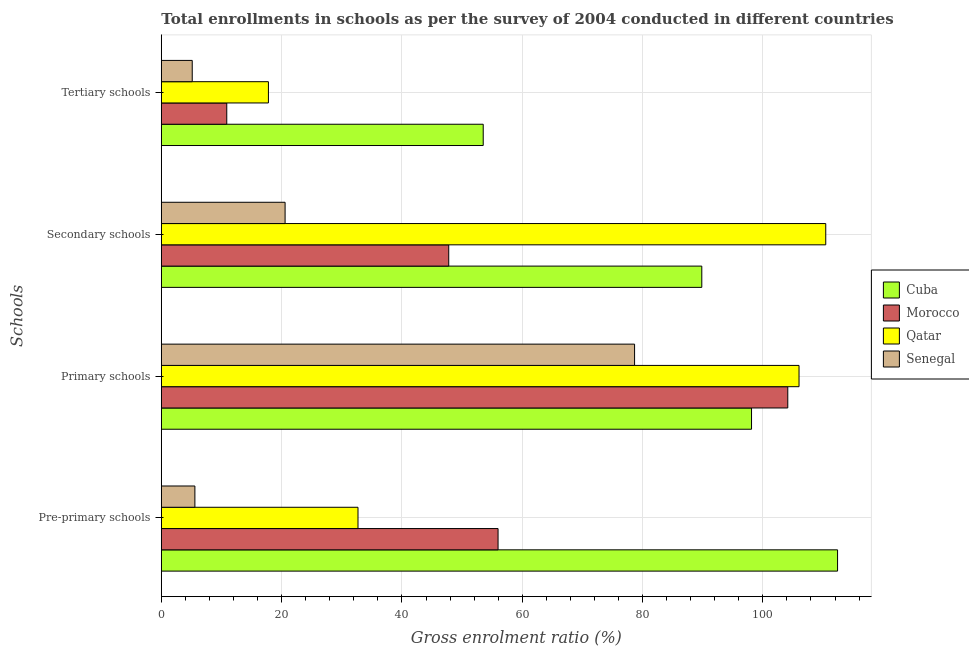How many different coloured bars are there?
Make the answer very short. 4. Are the number of bars per tick equal to the number of legend labels?
Offer a terse response. Yes. Are the number of bars on each tick of the Y-axis equal?
Ensure brevity in your answer.  Yes. How many bars are there on the 3rd tick from the bottom?
Give a very brief answer. 4. What is the label of the 2nd group of bars from the top?
Make the answer very short. Secondary schools. What is the gross enrolment ratio in tertiary schools in Cuba?
Offer a terse response. 53.51. Across all countries, what is the maximum gross enrolment ratio in pre-primary schools?
Provide a short and direct response. 112.42. Across all countries, what is the minimum gross enrolment ratio in tertiary schools?
Give a very brief answer. 5.14. In which country was the gross enrolment ratio in primary schools maximum?
Ensure brevity in your answer.  Qatar. In which country was the gross enrolment ratio in tertiary schools minimum?
Your response must be concise. Senegal. What is the total gross enrolment ratio in pre-primary schools in the graph?
Give a very brief answer. 206.68. What is the difference between the gross enrolment ratio in secondary schools in Qatar and that in Morocco?
Your answer should be compact. 62.67. What is the difference between the gross enrolment ratio in tertiary schools in Qatar and the gross enrolment ratio in primary schools in Morocco?
Give a very brief answer. -86.34. What is the average gross enrolment ratio in tertiary schools per country?
Offer a very short reply. 21.83. What is the difference between the gross enrolment ratio in primary schools and gross enrolment ratio in pre-primary schools in Qatar?
Offer a very short reply. 73.32. What is the ratio of the gross enrolment ratio in pre-primary schools in Morocco to that in Qatar?
Your answer should be very brief. 1.71. Is the difference between the gross enrolment ratio in secondary schools in Cuba and Senegal greater than the difference between the gross enrolment ratio in primary schools in Cuba and Senegal?
Your response must be concise. Yes. What is the difference between the highest and the second highest gross enrolment ratio in tertiary schools?
Provide a succinct answer. 35.71. What is the difference between the highest and the lowest gross enrolment ratio in primary schools?
Keep it short and to the point. 27.34. What does the 4th bar from the top in Secondary schools represents?
Provide a succinct answer. Cuba. What does the 3rd bar from the bottom in Secondary schools represents?
Keep it short and to the point. Qatar. Is it the case that in every country, the sum of the gross enrolment ratio in pre-primary schools and gross enrolment ratio in primary schools is greater than the gross enrolment ratio in secondary schools?
Give a very brief answer. Yes. How many bars are there?
Keep it short and to the point. 16. What is the difference between two consecutive major ticks on the X-axis?
Offer a very short reply. 20. Does the graph contain grids?
Provide a short and direct response. Yes. Where does the legend appear in the graph?
Offer a terse response. Center right. What is the title of the graph?
Your answer should be compact. Total enrollments in schools as per the survey of 2004 conducted in different countries. Does "Yemen, Rep." appear as one of the legend labels in the graph?
Give a very brief answer. No. What is the label or title of the Y-axis?
Make the answer very short. Schools. What is the Gross enrolment ratio (%) of Cuba in Pre-primary schools?
Your response must be concise. 112.42. What is the Gross enrolment ratio (%) in Morocco in Pre-primary schools?
Provide a short and direct response. 55.98. What is the Gross enrolment ratio (%) in Qatar in Pre-primary schools?
Provide a short and direct response. 32.7. What is the Gross enrolment ratio (%) of Senegal in Pre-primary schools?
Give a very brief answer. 5.58. What is the Gross enrolment ratio (%) in Cuba in Primary schools?
Offer a very short reply. 98.12. What is the Gross enrolment ratio (%) of Morocco in Primary schools?
Provide a short and direct response. 104.14. What is the Gross enrolment ratio (%) of Qatar in Primary schools?
Make the answer very short. 106.01. What is the Gross enrolment ratio (%) in Senegal in Primary schools?
Provide a succinct answer. 78.67. What is the Gross enrolment ratio (%) in Cuba in Secondary schools?
Keep it short and to the point. 89.85. What is the Gross enrolment ratio (%) of Morocco in Secondary schools?
Make the answer very short. 47.78. What is the Gross enrolment ratio (%) in Qatar in Secondary schools?
Your answer should be compact. 110.45. What is the Gross enrolment ratio (%) in Senegal in Secondary schools?
Your answer should be compact. 20.58. What is the Gross enrolment ratio (%) of Cuba in Tertiary schools?
Give a very brief answer. 53.51. What is the Gross enrolment ratio (%) in Morocco in Tertiary schools?
Give a very brief answer. 10.88. What is the Gross enrolment ratio (%) of Qatar in Tertiary schools?
Make the answer very short. 17.81. What is the Gross enrolment ratio (%) of Senegal in Tertiary schools?
Offer a terse response. 5.14. Across all Schools, what is the maximum Gross enrolment ratio (%) in Cuba?
Ensure brevity in your answer.  112.42. Across all Schools, what is the maximum Gross enrolment ratio (%) in Morocco?
Keep it short and to the point. 104.14. Across all Schools, what is the maximum Gross enrolment ratio (%) in Qatar?
Your response must be concise. 110.45. Across all Schools, what is the maximum Gross enrolment ratio (%) in Senegal?
Make the answer very short. 78.67. Across all Schools, what is the minimum Gross enrolment ratio (%) in Cuba?
Give a very brief answer. 53.51. Across all Schools, what is the minimum Gross enrolment ratio (%) of Morocco?
Offer a terse response. 10.88. Across all Schools, what is the minimum Gross enrolment ratio (%) of Qatar?
Your answer should be compact. 17.81. Across all Schools, what is the minimum Gross enrolment ratio (%) of Senegal?
Keep it short and to the point. 5.14. What is the total Gross enrolment ratio (%) in Cuba in the graph?
Offer a terse response. 353.89. What is the total Gross enrolment ratio (%) of Morocco in the graph?
Offer a very short reply. 218.78. What is the total Gross enrolment ratio (%) in Qatar in the graph?
Give a very brief answer. 266.97. What is the total Gross enrolment ratio (%) of Senegal in the graph?
Your response must be concise. 109.97. What is the difference between the Gross enrolment ratio (%) in Cuba in Pre-primary schools and that in Primary schools?
Offer a terse response. 14.3. What is the difference between the Gross enrolment ratio (%) of Morocco in Pre-primary schools and that in Primary schools?
Provide a succinct answer. -48.16. What is the difference between the Gross enrolment ratio (%) of Qatar in Pre-primary schools and that in Primary schools?
Your response must be concise. -73.32. What is the difference between the Gross enrolment ratio (%) of Senegal in Pre-primary schools and that in Primary schools?
Your answer should be very brief. -73.09. What is the difference between the Gross enrolment ratio (%) of Cuba in Pre-primary schools and that in Secondary schools?
Ensure brevity in your answer.  22.57. What is the difference between the Gross enrolment ratio (%) of Morocco in Pre-primary schools and that in Secondary schools?
Your answer should be compact. 8.2. What is the difference between the Gross enrolment ratio (%) of Qatar in Pre-primary schools and that in Secondary schools?
Your answer should be compact. -77.76. What is the difference between the Gross enrolment ratio (%) of Senegal in Pre-primary schools and that in Secondary schools?
Your response must be concise. -14.99. What is the difference between the Gross enrolment ratio (%) in Cuba in Pre-primary schools and that in Tertiary schools?
Your answer should be very brief. 58.91. What is the difference between the Gross enrolment ratio (%) of Morocco in Pre-primary schools and that in Tertiary schools?
Keep it short and to the point. 45.1. What is the difference between the Gross enrolment ratio (%) in Qatar in Pre-primary schools and that in Tertiary schools?
Keep it short and to the point. 14.89. What is the difference between the Gross enrolment ratio (%) in Senegal in Pre-primary schools and that in Tertiary schools?
Your response must be concise. 0.44. What is the difference between the Gross enrolment ratio (%) in Cuba in Primary schools and that in Secondary schools?
Offer a terse response. 8.27. What is the difference between the Gross enrolment ratio (%) in Morocco in Primary schools and that in Secondary schools?
Offer a terse response. 56.36. What is the difference between the Gross enrolment ratio (%) of Qatar in Primary schools and that in Secondary schools?
Provide a succinct answer. -4.44. What is the difference between the Gross enrolment ratio (%) of Senegal in Primary schools and that in Secondary schools?
Your response must be concise. 58.1. What is the difference between the Gross enrolment ratio (%) of Cuba in Primary schools and that in Tertiary schools?
Offer a very short reply. 44.6. What is the difference between the Gross enrolment ratio (%) in Morocco in Primary schools and that in Tertiary schools?
Make the answer very short. 93.26. What is the difference between the Gross enrolment ratio (%) of Qatar in Primary schools and that in Tertiary schools?
Your answer should be very brief. 88.21. What is the difference between the Gross enrolment ratio (%) of Senegal in Primary schools and that in Tertiary schools?
Give a very brief answer. 73.53. What is the difference between the Gross enrolment ratio (%) of Cuba in Secondary schools and that in Tertiary schools?
Give a very brief answer. 36.34. What is the difference between the Gross enrolment ratio (%) of Morocco in Secondary schools and that in Tertiary schools?
Offer a terse response. 36.9. What is the difference between the Gross enrolment ratio (%) of Qatar in Secondary schools and that in Tertiary schools?
Provide a succinct answer. 92.65. What is the difference between the Gross enrolment ratio (%) in Senegal in Secondary schools and that in Tertiary schools?
Your answer should be very brief. 15.44. What is the difference between the Gross enrolment ratio (%) of Cuba in Pre-primary schools and the Gross enrolment ratio (%) of Morocco in Primary schools?
Give a very brief answer. 8.28. What is the difference between the Gross enrolment ratio (%) in Cuba in Pre-primary schools and the Gross enrolment ratio (%) in Qatar in Primary schools?
Your answer should be very brief. 6.41. What is the difference between the Gross enrolment ratio (%) of Cuba in Pre-primary schools and the Gross enrolment ratio (%) of Senegal in Primary schools?
Keep it short and to the point. 33.75. What is the difference between the Gross enrolment ratio (%) in Morocco in Pre-primary schools and the Gross enrolment ratio (%) in Qatar in Primary schools?
Your response must be concise. -50.03. What is the difference between the Gross enrolment ratio (%) in Morocco in Pre-primary schools and the Gross enrolment ratio (%) in Senegal in Primary schools?
Offer a terse response. -22.69. What is the difference between the Gross enrolment ratio (%) of Qatar in Pre-primary schools and the Gross enrolment ratio (%) of Senegal in Primary schools?
Your answer should be compact. -45.98. What is the difference between the Gross enrolment ratio (%) in Cuba in Pre-primary schools and the Gross enrolment ratio (%) in Morocco in Secondary schools?
Give a very brief answer. 64.64. What is the difference between the Gross enrolment ratio (%) in Cuba in Pre-primary schools and the Gross enrolment ratio (%) in Qatar in Secondary schools?
Offer a terse response. 1.97. What is the difference between the Gross enrolment ratio (%) of Cuba in Pre-primary schools and the Gross enrolment ratio (%) of Senegal in Secondary schools?
Offer a very short reply. 91.84. What is the difference between the Gross enrolment ratio (%) in Morocco in Pre-primary schools and the Gross enrolment ratio (%) in Qatar in Secondary schools?
Offer a terse response. -54.47. What is the difference between the Gross enrolment ratio (%) of Morocco in Pre-primary schools and the Gross enrolment ratio (%) of Senegal in Secondary schools?
Keep it short and to the point. 35.4. What is the difference between the Gross enrolment ratio (%) in Qatar in Pre-primary schools and the Gross enrolment ratio (%) in Senegal in Secondary schools?
Provide a short and direct response. 12.12. What is the difference between the Gross enrolment ratio (%) in Cuba in Pre-primary schools and the Gross enrolment ratio (%) in Morocco in Tertiary schools?
Make the answer very short. 101.54. What is the difference between the Gross enrolment ratio (%) in Cuba in Pre-primary schools and the Gross enrolment ratio (%) in Qatar in Tertiary schools?
Your answer should be compact. 94.61. What is the difference between the Gross enrolment ratio (%) in Cuba in Pre-primary schools and the Gross enrolment ratio (%) in Senegal in Tertiary schools?
Your answer should be very brief. 107.28. What is the difference between the Gross enrolment ratio (%) in Morocco in Pre-primary schools and the Gross enrolment ratio (%) in Qatar in Tertiary schools?
Give a very brief answer. 38.17. What is the difference between the Gross enrolment ratio (%) of Morocco in Pre-primary schools and the Gross enrolment ratio (%) of Senegal in Tertiary schools?
Make the answer very short. 50.84. What is the difference between the Gross enrolment ratio (%) of Qatar in Pre-primary schools and the Gross enrolment ratio (%) of Senegal in Tertiary schools?
Your answer should be compact. 27.56. What is the difference between the Gross enrolment ratio (%) in Cuba in Primary schools and the Gross enrolment ratio (%) in Morocco in Secondary schools?
Provide a succinct answer. 50.34. What is the difference between the Gross enrolment ratio (%) in Cuba in Primary schools and the Gross enrolment ratio (%) in Qatar in Secondary schools?
Keep it short and to the point. -12.34. What is the difference between the Gross enrolment ratio (%) of Cuba in Primary schools and the Gross enrolment ratio (%) of Senegal in Secondary schools?
Make the answer very short. 77.54. What is the difference between the Gross enrolment ratio (%) of Morocco in Primary schools and the Gross enrolment ratio (%) of Qatar in Secondary schools?
Keep it short and to the point. -6.31. What is the difference between the Gross enrolment ratio (%) of Morocco in Primary schools and the Gross enrolment ratio (%) of Senegal in Secondary schools?
Give a very brief answer. 83.56. What is the difference between the Gross enrolment ratio (%) in Qatar in Primary schools and the Gross enrolment ratio (%) in Senegal in Secondary schools?
Provide a short and direct response. 85.43. What is the difference between the Gross enrolment ratio (%) in Cuba in Primary schools and the Gross enrolment ratio (%) in Morocco in Tertiary schools?
Provide a short and direct response. 87.24. What is the difference between the Gross enrolment ratio (%) of Cuba in Primary schools and the Gross enrolment ratio (%) of Qatar in Tertiary schools?
Provide a short and direct response. 80.31. What is the difference between the Gross enrolment ratio (%) in Cuba in Primary schools and the Gross enrolment ratio (%) in Senegal in Tertiary schools?
Your answer should be very brief. 92.98. What is the difference between the Gross enrolment ratio (%) in Morocco in Primary schools and the Gross enrolment ratio (%) in Qatar in Tertiary schools?
Offer a very short reply. 86.34. What is the difference between the Gross enrolment ratio (%) of Morocco in Primary schools and the Gross enrolment ratio (%) of Senegal in Tertiary schools?
Give a very brief answer. 99. What is the difference between the Gross enrolment ratio (%) of Qatar in Primary schools and the Gross enrolment ratio (%) of Senegal in Tertiary schools?
Your answer should be very brief. 100.87. What is the difference between the Gross enrolment ratio (%) in Cuba in Secondary schools and the Gross enrolment ratio (%) in Morocco in Tertiary schools?
Provide a short and direct response. 78.97. What is the difference between the Gross enrolment ratio (%) in Cuba in Secondary schools and the Gross enrolment ratio (%) in Qatar in Tertiary schools?
Your answer should be compact. 72.04. What is the difference between the Gross enrolment ratio (%) of Cuba in Secondary schools and the Gross enrolment ratio (%) of Senegal in Tertiary schools?
Your response must be concise. 84.71. What is the difference between the Gross enrolment ratio (%) of Morocco in Secondary schools and the Gross enrolment ratio (%) of Qatar in Tertiary schools?
Make the answer very short. 29.97. What is the difference between the Gross enrolment ratio (%) in Morocco in Secondary schools and the Gross enrolment ratio (%) in Senegal in Tertiary schools?
Offer a terse response. 42.64. What is the difference between the Gross enrolment ratio (%) of Qatar in Secondary schools and the Gross enrolment ratio (%) of Senegal in Tertiary schools?
Offer a very short reply. 105.31. What is the average Gross enrolment ratio (%) of Cuba per Schools?
Make the answer very short. 88.47. What is the average Gross enrolment ratio (%) in Morocco per Schools?
Keep it short and to the point. 54.7. What is the average Gross enrolment ratio (%) of Qatar per Schools?
Your answer should be compact. 66.74. What is the average Gross enrolment ratio (%) in Senegal per Schools?
Provide a short and direct response. 27.49. What is the difference between the Gross enrolment ratio (%) of Cuba and Gross enrolment ratio (%) of Morocco in Pre-primary schools?
Your answer should be very brief. 56.44. What is the difference between the Gross enrolment ratio (%) of Cuba and Gross enrolment ratio (%) of Qatar in Pre-primary schools?
Your response must be concise. 79.72. What is the difference between the Gross enrolment ratio (%) of Cuba and Gross enrolment ratio (%) of Senegal in Pre-primary schools?
Keep it short and to the point. 106.84. What is the difference between the Gross enrolment ratio (%) in Morocco and Gross enrolment ratio (%) in Qatar in Pre-primary schools?
Your answer should be compact. 23.28. What is the difference between the Gross enrolment ratio (%) in Morocco and Gross enrolment ratio (%) in Senegal in Pre-primary schools?
Your answer should be very brief. 50.4. What is the difference between the Gross enrolment ratio (%) in Qatar and Gross enrolment ratio (%) in Senegal in Pre-primary schools?
Your answer should be very brief. 27.11. What is the difference between the Gross enrolment ratio (%) of Cuba and Gross enrolment ratio (%) of Morocco in Primary schools?
Provide a succinct answer. -6.03. What is the difference between the Gross enrolment ratio (%) of Cuba and Gross enrolment ratio (%) of Qatar in Primary schools?
Offer a very short reply. -7.9. What is the difference between the Gross enrolment ratio (%) in Cuba and Gross enrolment ratio (%) in Senegal in Primary schools?
Your response must be concise. 19.44. What is the difference between the Gross enrolment ratio (%) in Morocco and Gross enrolment ratio (%) in Qatar in Primary schools?
Keep it short and to the point. -1.87. What is the difference between the Gross enrolment ratio (%) in Morocco and Gross enrolment ratio (%) in Senegal in Primary schools?
Provide a short and direct response. 25.47. What is the difference between the Gross enrolment ratio (%) in Qatar and Gross enrolment ratio (%) in Senegal in Primary schools?
Provide a succinct answer. 27.34. What is the difference between the Gross enrolment ratio (%) in Cuba and Gross enrolment ratio (%) in Morocco in Secondary schools?
Make the answer very short. 42.07. What is the difference between the Gross enrolment ratio (%) of Cuba and Gross enrolment ratio (%) of Qatar in Secondary schools?
Give a very brief answer. -20.6. What is the difference between the Gross enrolment ratio (%) of Cuba and Gross enrolment ratio (%) of Senegal in Secondary schools?
Ensure brevity in your answer.  69.27. What is the difference between the Gross enrolment ratio (%) in Morocco and Gross enrolment ratio (%) in Qatar in Secondary schools?
Offer a very short reply. -62.67. What is the difference between the Gross enrolment ratio (%) of Morocco and Gross enrolment ratio (%) of Senegal in Secondary schools?
Your response must be concise. 27.2. What is the difference between the Gross enrolment ratio (%) in Qatar and Gross enrolment ratio (%) in Senegal in Secondary schools?
Provide a succinct answer. 89.88. What is the difference between the Gross enrolment ratio (%) in Cuba and Gross enrolment ratio (%) in Morocco in Tertiary schools?
Your response must be concise. 42.63. What is the difference between the Gross enrolment ratio (%) of Cuba and Gross enrolment ratio (%) of Qatar in Tertiary schools?
Ensure brevity in your answer.  35.71. What is the difference between the Gross enrolment ratio (%) of Cuba and Gross enrolment ratio (%) of Senegal in Tertiary schools?
Make the answer very short. 48.37. What is the difference between the Gross enrolment ratio (%) in Morocco and Gross enrolment ratio (%) in Qatar in Tertiary schools?
Your answer should be compact. -6.93. What is the difference between the Gross enrolment ratio (%) in Morocco and Gross enrolment ratio (%) in Senegal in Tertiary schools?
Provide a succinct answer. 5.74. What is the difference between the Gross enrolment ratio (%) of Qatar and Gross enrolment ratio (%) of Senegal in Tertiary schools?
Ensure brevity in your answer.  12.67. What is the ratio of the Gross enrolment ratio (%) in Cuba in Pre-primary schools to that in Primary schools?
Your response must be concise. 1.15. What is the ratio of the Gross enrolment ratio (%) in Morocco in Pre-primary schools to that in Primary schools?
Offer a very short reply. 0.54. What is the ratio of the Gross enrolment ratio (%) in Qatar in Pre-primary schools to that in Primary schools?
Provide a short and direct response. 0.31. What is the ratio of the Gross enrolment ratio (%) in Senegal in Pre-primary schools to that in Primary schools?
Your response must be concise. 0.07. What is the ratio of the Gross enrolment ratio (%) of Cuba in Pre-primary schools to that in Secondary schools?
Keep it short and to the point. 1.25. What is the ratio of the Gross enrolment ratio (%) in Morocco in Pre-primary schools to that in Secondary schools?
Provide a succinct answer. 1.17. What is the ratio of the Gross enrolment ratio (%) in Qatar in Pre-primary schools to that in Secondary schools?
Provide a short and direct response. 0.3. What is the ratio of the Gross enrolment ratio (%) of Senegal in Pre-primary schools to that in Secondary schools?
Make the answer very short. 0.27. What is the ratio of the Gross enrolment ratio (%) in Cuba in Pre-primary schools to that in Tertiary schools?
Keep it short and to the point. 2.1. What is the ratio of the Gross enrolment ratio (%) in Morocco in Pre-primary schools to that in Tertiary schools?
Your answer should be very brief. 5.15. What is the ratio of the Gross enrolment ratio (%) of Qatar in Pre-primary schools to that in Tertiary schools?
Give a very brief answer. 1.84. What is the ratio of the Gross enrolment ratio (%) in Senegal in Pre-primary schools to that in Tertiary schools?
Offer a terse response. 1.09. What is the ratio of the Gross enrolment ratio (%) of Cuba in Primary schools to that in Secondary schools?
Offer a terse response. 1.09. What is the ratio of the Gross enrolment ratio (%) of Morocco in Primary schools to that in Secondary schools?
Make the answer very short. 2.18. What is the ratio of the Gross enrolment ratio (%) of Qatar in Primary schools to that in Secondary schools?
Your response must be concise. 0.96. What is the ratio of the Gross enrolment ratio (%) in Senegal in Primary schools to that in Secondary schools?
Provide a short and direct response. 3.82. What is the ratio of the Gross enrolment ratio (%) in Cuba in Primary schools to that in Tertiary schools?
Provide a short and direct response. 1.83. What is the ratio of the Gross enrolment ratio (%) in Morocco in Primary schools to that in Tertiary schools?
Keep it short and to the point. 9.57. What is the ratio of the Gross enrolment ratio (%) in Qatar in Primary schools to that in Tertiary schools?
Make the answer very short. 5.95. What is the ratio of the Gross enrolment ratio (%) in Senegal in Primary schools to that in Tertiary schools?
Your response must be concise. 15.31. What is the ratio of the Gross enrolment ratio (%) in Cuba in Secondary schools to that in Tertiary schools?
Your answer should be compact. 1.68. What is the ratio of the Gross enrolment ratio (%) in Morocco in Secondary schools to that in Tertiary schools?
Keep it short and to the point. 4.39. What is the ratio of the Gross enrolment ratio (%) of Qatar in Secondary schools to that in Tertiary schools?
Your answer should be compact. 6.2. What is the ratio of the Gross enrolment ratio (%) in Senegal in Secondary schools to that in Tertiary schools?
Give a very brief answer. 4. What is the difference between the highest and the second highest Gross enrolment ratio (%) of Cuba?
Your answer should be compact. 14.3. What is the difference between the highest and the second highest Gross enrolment ratio (%) in Morocco?
Give a very brief answer. 48.16. What is the difference between the highest and the second highest Gross enrolment ratio (%) in Qatar?
Your answer should be compact. 4.44. What is the difference between the highest and the second highest Gross enrolment ratio (%) in Senegal?
Offer a very short reply. 58.1. What is the difference between the highest and the lowest Gross enrolment ratio (%) of Cuba?
Make the answer very short. 58.91. What is the difference between the highest and the lowest Gross enrolment ratio (%) in Morocco?
Offer a very short reply. 93.26. What is the difference between the highest and the lowest Gross enrolment ratio (%) of Qatar?
Give a very brief answer. 92.65. What is the difference between the highest and the lowest Gross enrolment ratio (%) of Senegal?
Provide a succinct answer. 73.53. 